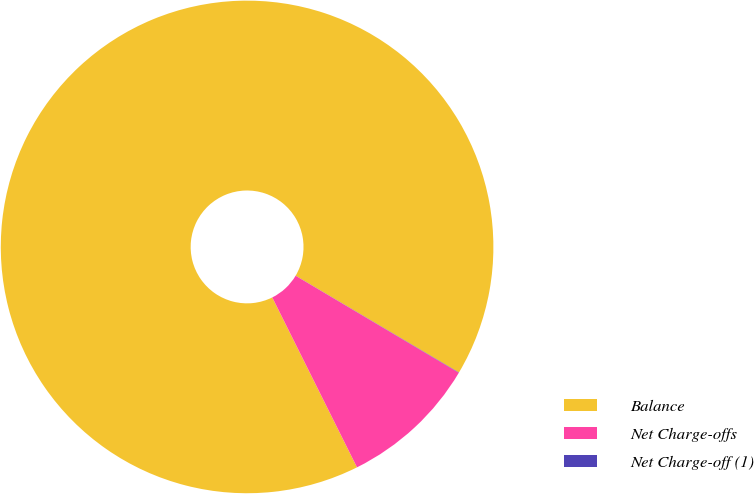Convert chart. <chart><loc_0><loc_0><loc_500><loc_500><pie_chart><fcel>Balance<fcel>Net Charge-offs<fcel>Net Charge-off (1)<nl><fcel>90.88%<fcel>9.1%<fcel>0.02%<nl></chart> 